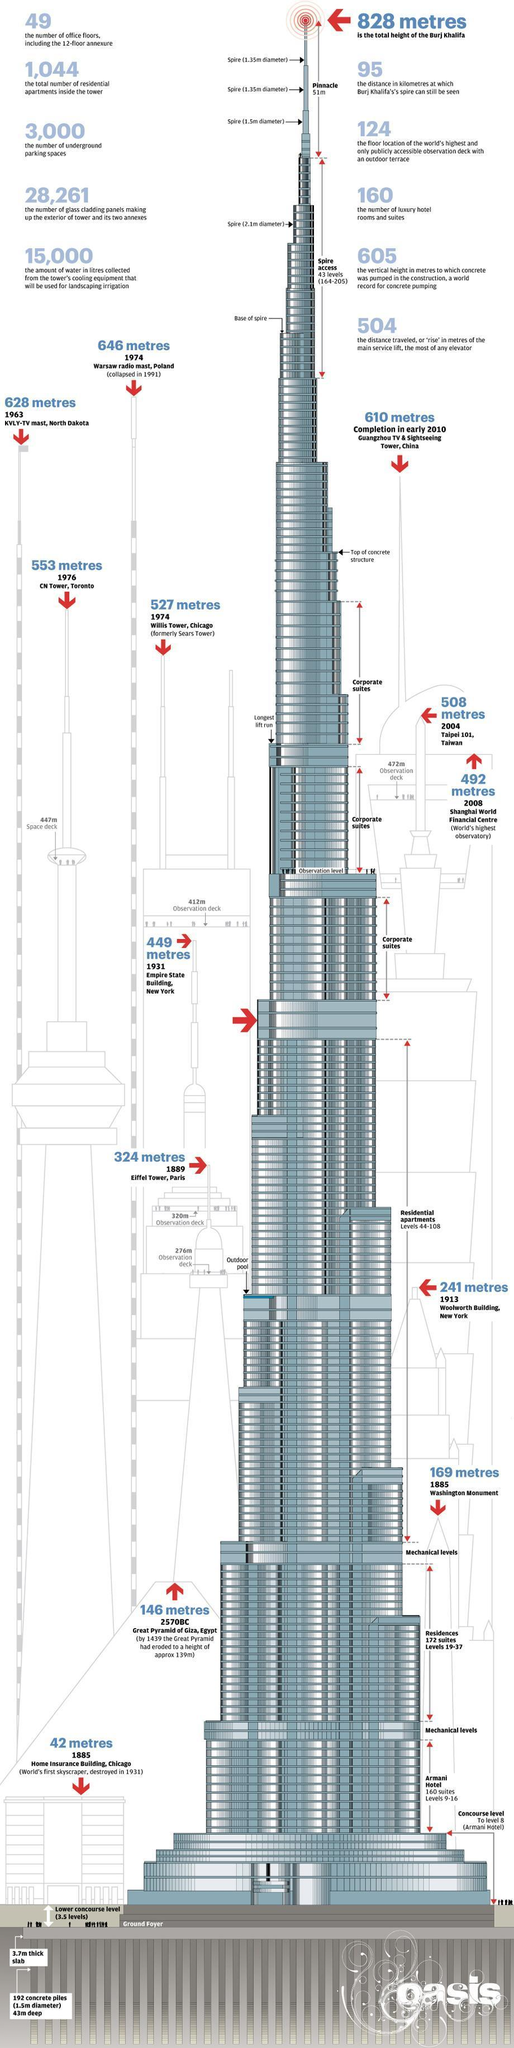Which floor levels in Burj Khalifa constitute the Armani Hotel?
Answer the question with a short phrase. Levels 9-16 What is the number of luxury hotel rooms and suites in Burj Khalifa? 160 How many residence suites are there in levels 19-37 floors of Burj Khalifa? 172 suites What is the height of Eiffel Tower in Paris? 324 metres What is the height of Willis Tower in Chicago? 527 metres Which floor levels in Burj Khalifa constitute the Residential apartments? Levels 44-108 What is the pinnacle height of Burj Khalifa? 51m What is the total number of residential apartments inside the tower? 1,044 What is the height of Shanghai World Financial Centre build in 2008? 492 metres What is the number of underground parking spaces available in Burj Khalifa? 3,000 